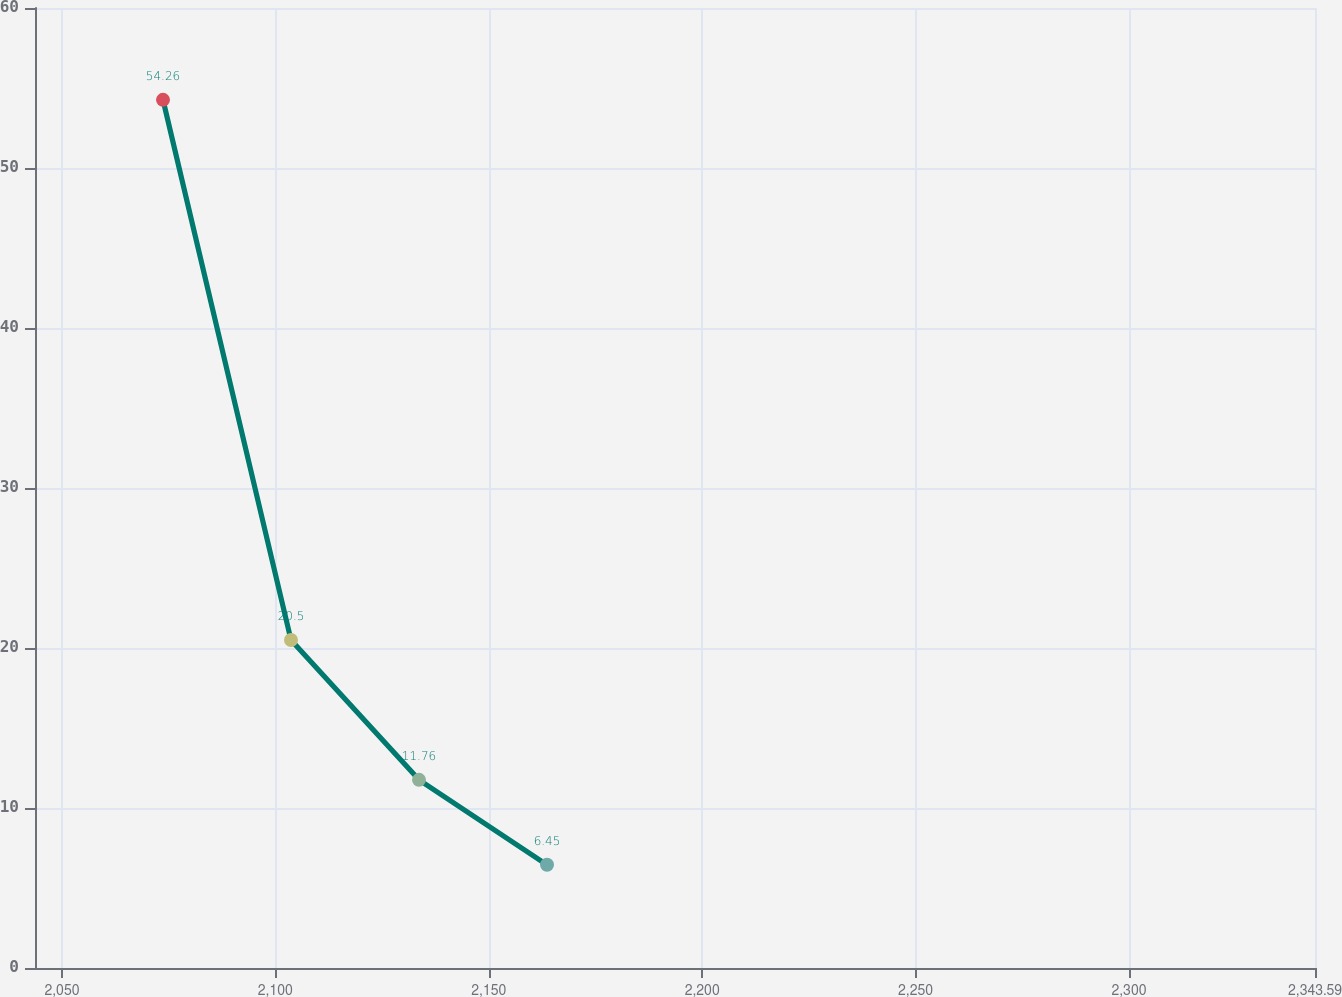Convert chart to OTSL. <chart><loc_0><loc_0><loc_500><loc_500><line_chart><ecel><fcel>Amount<nl><fcel>2073.68<fcel>54.26<nl><fcel>2103.67<fcel>20.5<nl><fcel>2133.66<fcel>11.76<nl><fcel>2163.65<fcel>6.45<nl><fcel>2373.58<fcel>1.14<nl></chart> 